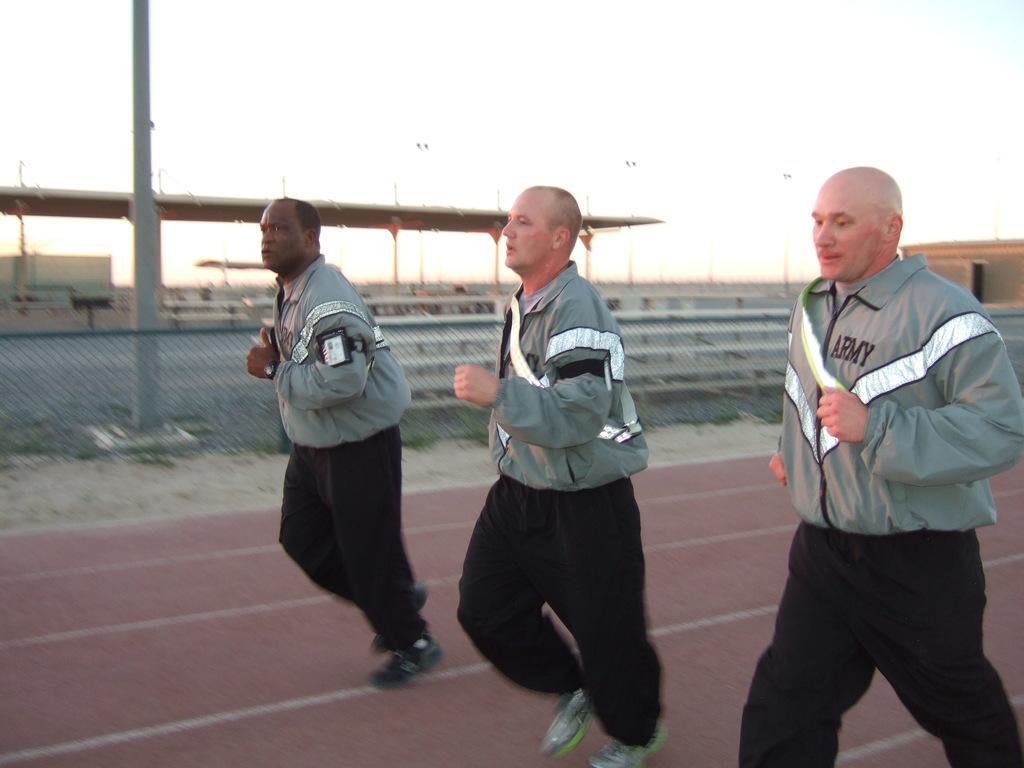Please provide a concise description of this image. There are three men running on the ground. In the background there are fences,poles,on the left and right there is a building,some other objects and sky. 